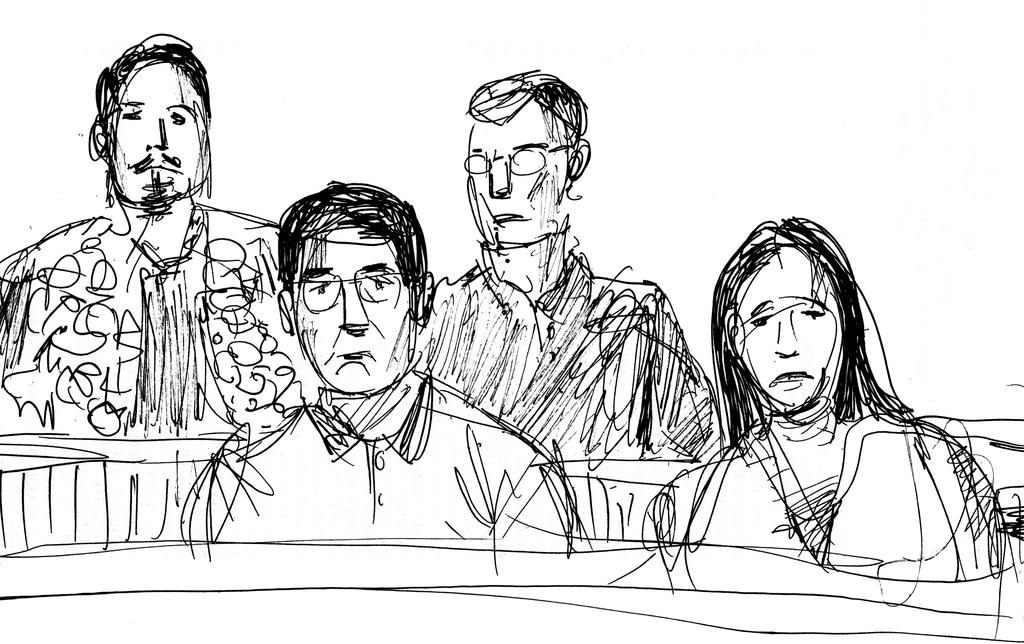What type of image is being described? The image is a drawing. How many people are depicted in the drawing? There are three persons in the drawing. Can you describe one of the individuals in the drawing? There is a woman in the drawing. What year is depicted in the drawing? The drawing does not depict a specific year; it is a drawing of three persons, including a woman. 